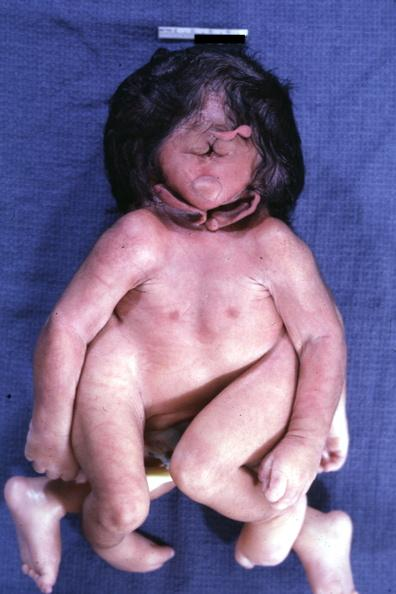what does this image show?
Answer the question using a single word or phrase. Conjoined twins at head and chest 